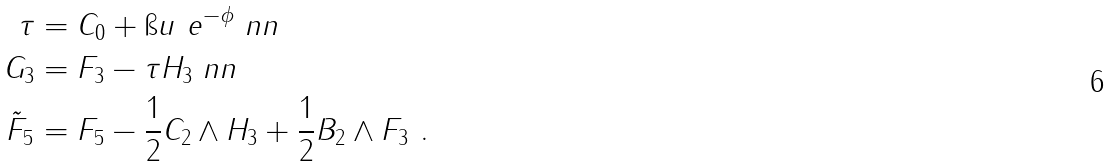<formula> <loc_0><loc_0><loc_500><loc_500>\tau & = C _ { 0 } + \i u \ e ^ { - \phi } \ n n \\ G _ { 3 } & = F _ { 3 } - \tau H _ { 3 } \ n n \\ \tilde { F } _ { 5 } & = F _ { 5 } - \frac { 1 } { 2 } C _ { 2 } \wedge H _ { 3 } + \frac { 1 } { 2 } B _ { 2 } \wedge F _ { 3 } \ .</formula> 